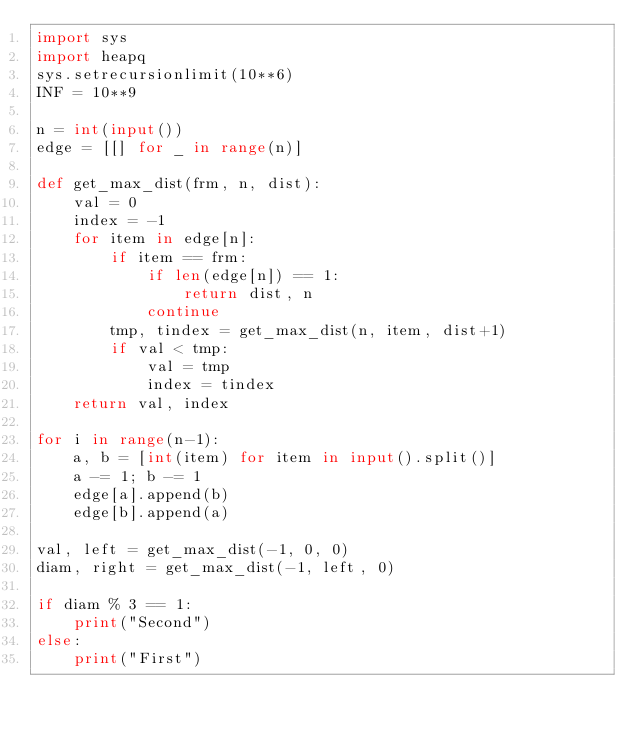Convert code to text. <code><loc_0><loc_0><loc_500><loc_500><_Python_>import sys
import heapq
sys.setrecursionlimit(10**6)
INF = 10**9

n = int(input())
edge = [[] for _ in range(n)]

def get_max_dist(frm, n, dist):
    val = 0
    index = -1
    for item in edge[n]:
        if item == frm:
            if len(edge[n]) == 1:
                return dist, n
            continue
        tmp, tindex = get_max_dist(n, item, dist+1)
        if val < tmp:
            val = tmp
            index = tindex
    return val, index

for i in range(n-1):
    a, b = [int(item) for item in input().split()]
    a -= 1; b -= 1
    edge[a].append(b)
    edge[b].append(a)

val, left = get_max_dist(-1, 0, 0)
diam, right = get_max_dist(-1, left, 0)

if diam % 3 == 1:
    print("Second")
else:
    print("First")</code> 